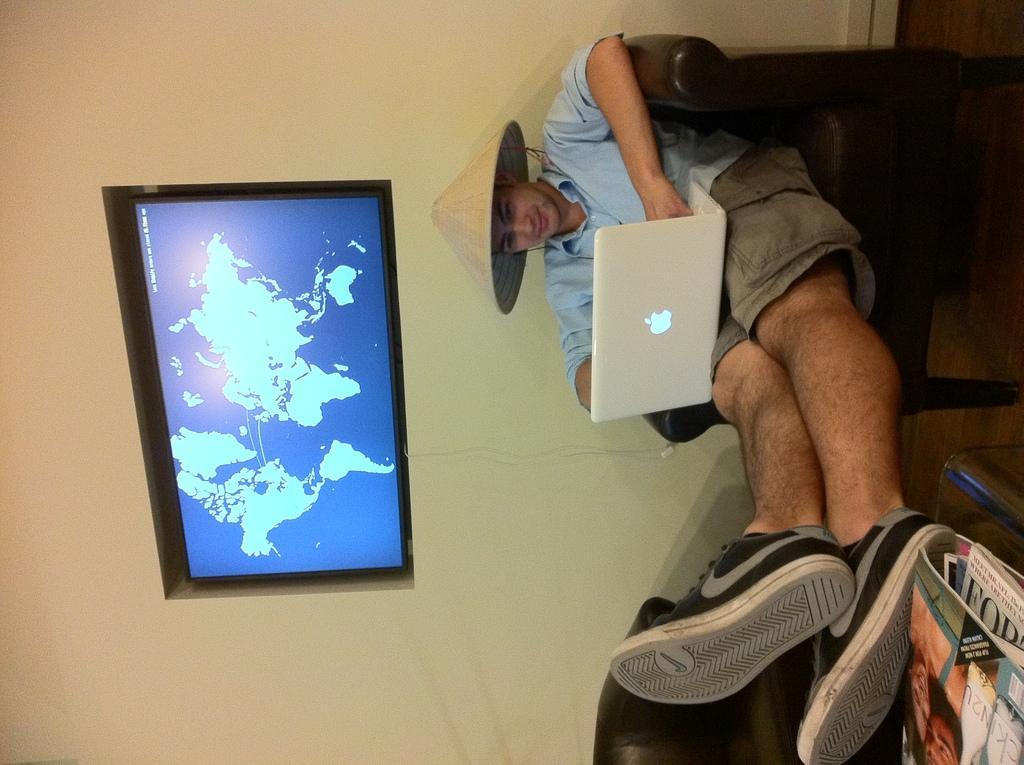Describe this image in one or two sentences. This picture shows a man seated in the chair and he wore a cap on his head and a laptop on his legs and we see a television to the wall and books on the table. 